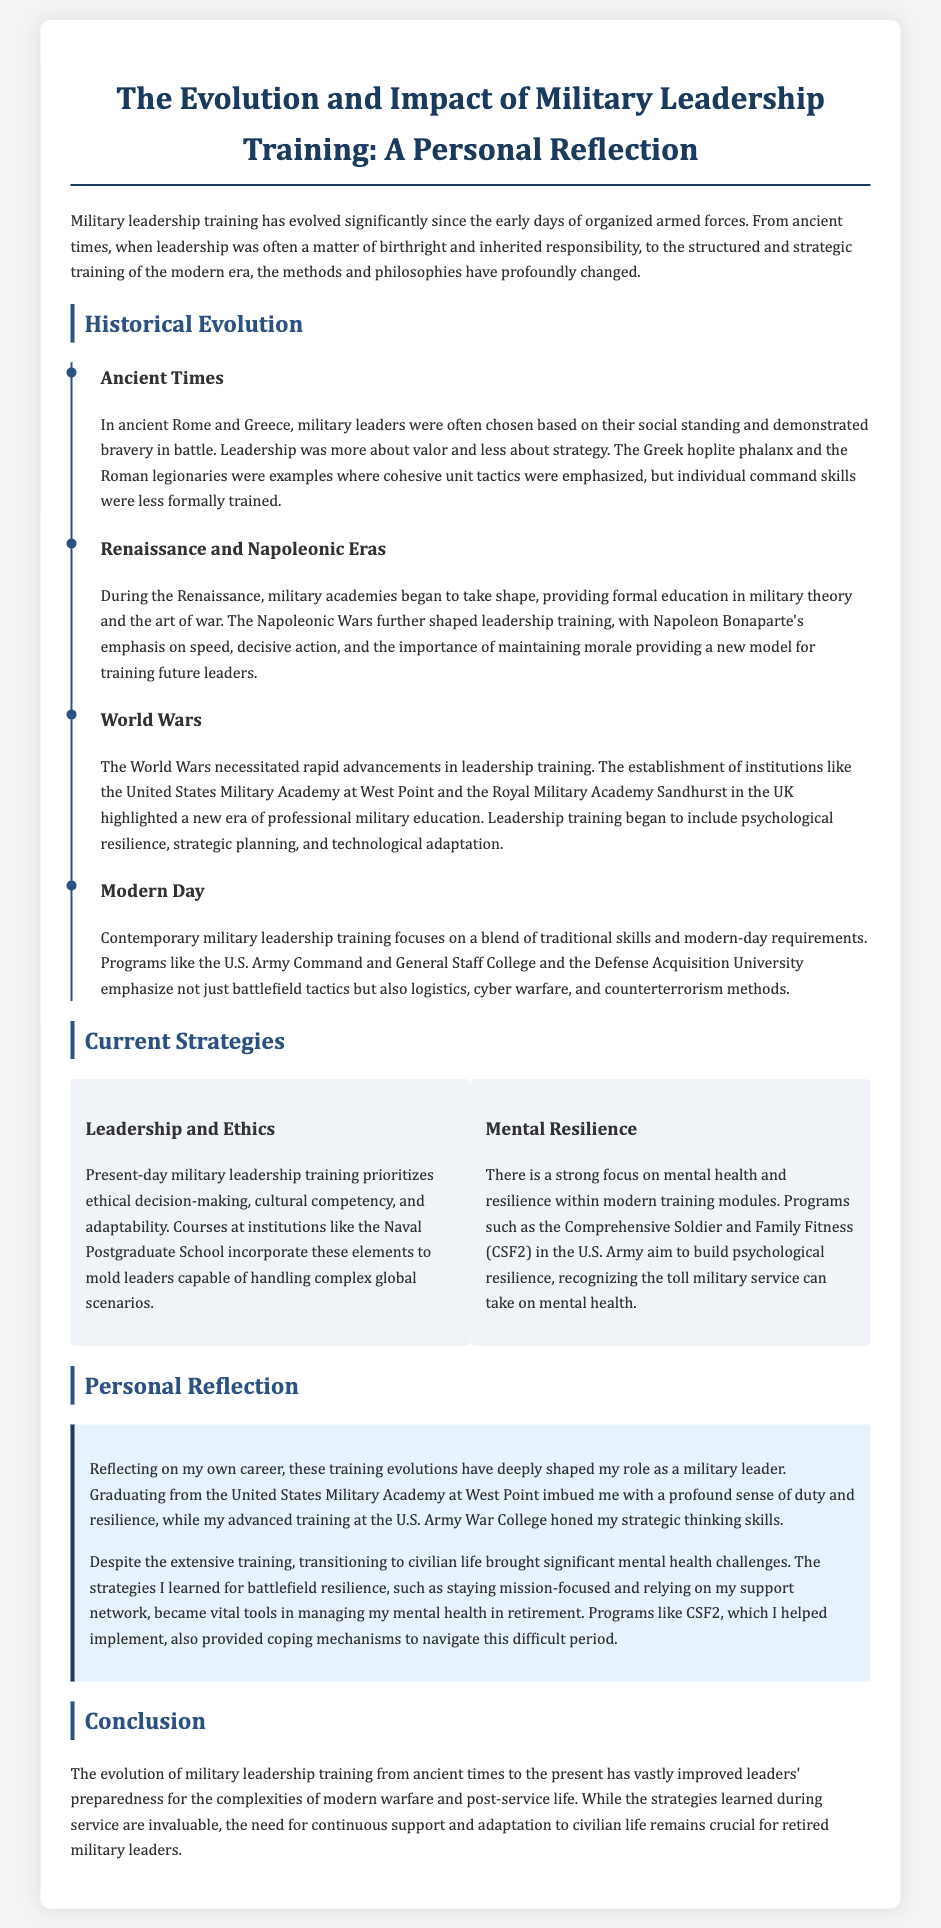What are the main eras of military leadership evolution mentioned? The document highlights Ancient Times, Renaissance and Napoleonic Eras, World Wars, and Modern Day as the main eras of military leadership evolution.
Answer: Ancient Times, Renaissance and Napoleonic Eras, World Wars, Modern Day Which military academy is mentioned in connection with the establishment of professional military education? The document mentions the United States Military Academy at West Point as an institution that established professional military education.
Answer: United States Military Academy at West Point What focus has been emphasized in modern military leadership training regarding ethics? The current strategies section of the document states that modern training prioritizes ethical decision-making.
Answer: Ethical decision-making What are the two current strategies outlined in the document? The document outlines Leadership and Ethics and Mental Resilience as two current strategies in military leadership training.
Answer: Leadership and Ethics, Mental Resilience Which program is mentioned as aiming to build psychological resilience? The document identifies the Comprehensive Soldier and Family Fitness (CSF2) program as aimed at building psychological resilience.
Answer: Comprehensive Soldier and Family Fitness (CSF2) How did the author's training affect their transition to civilian life? The author reflects that the strategies learned for battlefield resilience became vital tools in managing mental health during retirement.
Answer: Vital tools for managing mental health What significant challenge did the author face after retiring? The author faced significant mental health challenges after retiring from military service.
Answer: Mental health challenges What institution is mentioned for advanced training in the author's career? The U.S. Army War College is mentioned as an institution where the author received advanced training.
Answer: U.S. Army War College 